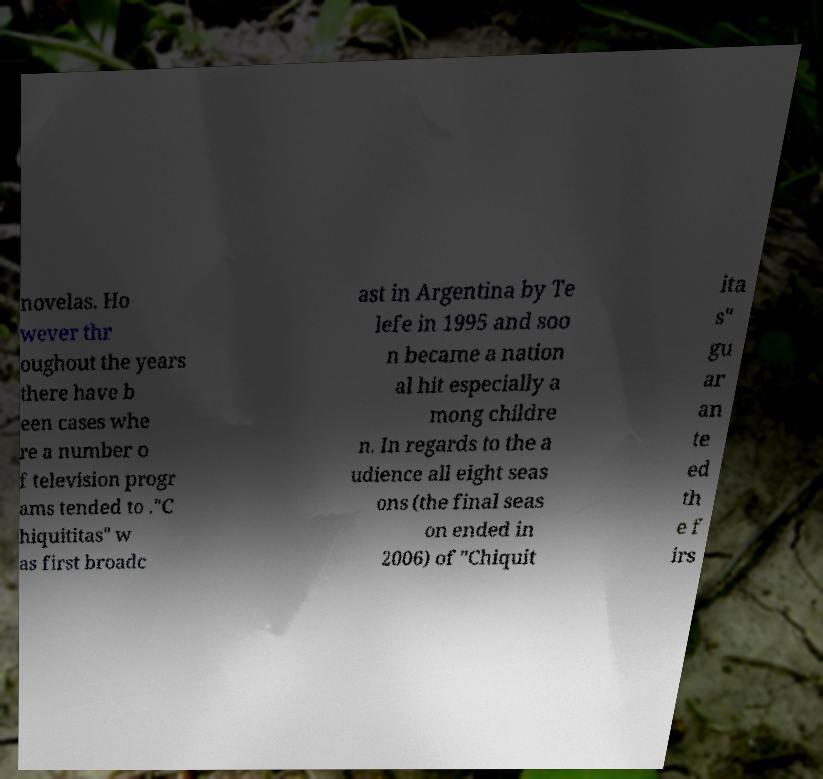Please read and relay the text visible in this image. What does it say? novelas. Ho wever thr oughout the years there have b een cases whe re a number o f television progr ams tended to ."C hiquititas" w as first broadc ast in Argentina by Te lefe in 1995 and soo n became a nation al hit especially a mong childre n. In regards to the a udience all eight seas ons (the final seas on ended in 2006) of "Chiquit ita s" gu ar an te ed th e f irs 